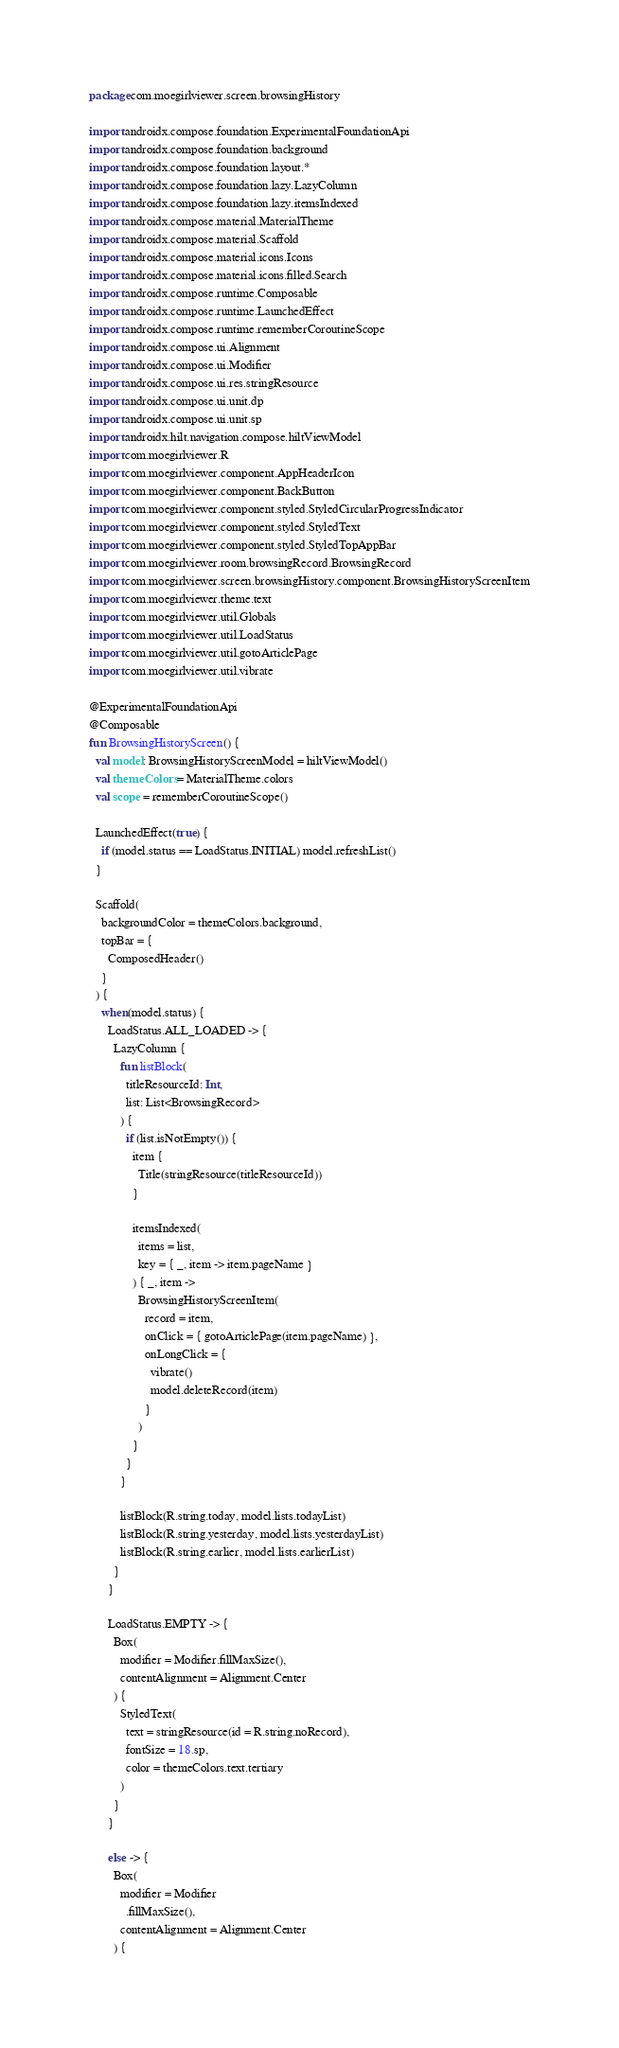Convert code to text. <code><loc_0><loc_0><loc_500><loc_500><_Kotlin_>package com.moegirlviewer.screen.browsingHistory

import androidx.compose.foundation.ExperimentalFoundationApi
import androidx.compose.foundation.background
import androidx.compose.foundation.layout.*
import androidx.compose.foundation.lazy.LazyColumn
import androidx.compose.foundation.lazy.itemsIndexed
import androidx.compose.material.MaterialTheme
import androidx.compose.material.Scaffold
import androidx.compose.material.icons.Icons
import androidx.compose.material.icons.filled.Search
import androidx.compose.runtime.Composable
import androidx.compose.runtime.LaunchedEffect
import androidx.compose.runtime.rememberCoroutineScope
import androidx.compose.ui.Alignment
import androidx.compose.ui.Modifier
import androidx.compose.ui.res.stringResource
import androidx.compose.ui.unit.dp
import androidx.compose.ui.unit.sp
import androidx.hilt.navigation.compose.hiltViewModel
import com.moegirlviewer.R
import com.moegirlviewer.component.AppHeaderIcon
import com.moegirlviewer.component.BackButton
import com.moegirlviewer.component.styled.StyledCircularProgressIndicator
import com.moegirlviewer.component.styled.StyledText
import com.moegirlviewer.component.styled.StyledTopAppBar
import com.moegirlviewer.room.browsingRecord.BrowsingRecord
import com.moegirlviewer.screen.browsingHistory.component.BrowsingHistoryScreenItem
import com.moegirlviewer.theme.text
import com.moegirlviewer.util.Globals
import com.moegirlviewer.util.LoadStatus
import com.moegirlviewer.util.gotoArticlePage
import com.moegirlviewer.util.vibrate

@ExperimentalFoundationApi
@Composable
fun BrowsingHistoryScreen() {
  val model: BrowsingHistoryScreenModel = hiltViewModel()
  val themeColors = MaterialTheme.colors
  val scope = rememberCoroutineScope()

  LaunchedEffect(true) {
    if (model.status == LoadStatus.INITIAL) model.refreshList()
  }

  Scaffold(
    backgroundColor = themeColors.background,
    topBar = {
      ComposedHeader()
    }
  ) {
    when(model.status) {
      LoadStatus.ALL_LOADED -> {
        LazyColumn {
          fun listBlock(
            titleResourceId: Int,
            list: List<BrowsingRecord>
          ) {
            if (list.isNotEmpty()) {
              item {
                Title(stringResource(titleResourceId))
              }

              itemsIndexed(
                items = list,
                key = { _, item -> item.pageName }
              ) { _, item ->
                BrowsingHistoryScreenItem(
                  record = item,
                  onClick = { gotoArticlePage(item.pageName) },
                  onLongClick = {
                    vibrate()
                    model.deleteRecord(item)
                  }
                )
              }
            }
          }

          listBlock(R.string.today, model.lists.todayList)
          listBlock(R.string.yesterday, model.lists.yesterdayList)
          listBlock(R.string.earlier, model.lists.earlierList)
        }
      }

      LoadStatus.EMPTY -> {
        Box(
          modifier = Modifier.fillMaxSize(),
          contentAlignment = Alignment.Center
        ) {
          StyledText(
            text = stringResource(id = R.string.noRecord),
            fontSize = 18.sp,
            color = themeColors.text.tertiary
          )
        }
      }

      else -> {
        Box(
          modifier = Modifier
            .fillMaxSize(),
          contentAlignment = Alignment.Center
        ) {</code> 